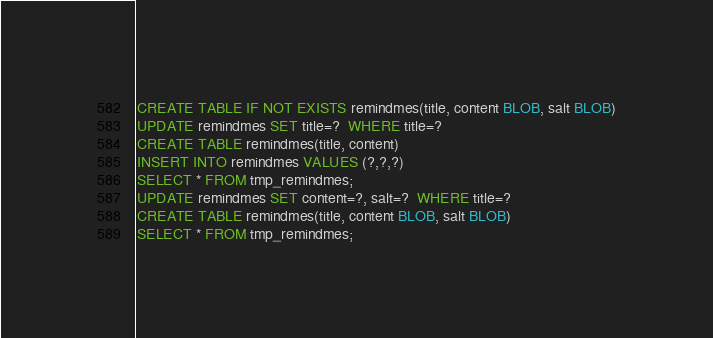Convert code to text. <code><loc_0><loc_0><loc_500><loc_500><_SQL_>CREATE TABLE IF NOT EXISTS remindmes(title, content BLOB, salt BLOB)
UPDATE remindmes SET title=?  WHERE title=?
CREATE TABLE remindmes(title, content)
INSERT INTO remindmes VALUES (?,?,?)
SELECT * FROM tmp_remindmes;
UPDATE remindmes SET content=?, salt=?  WHERE title=?
CREATE TABLE remindmes(title, content BLOB, salt BLOB)
SELECT * FROM tmp_remindmes;
</code> 